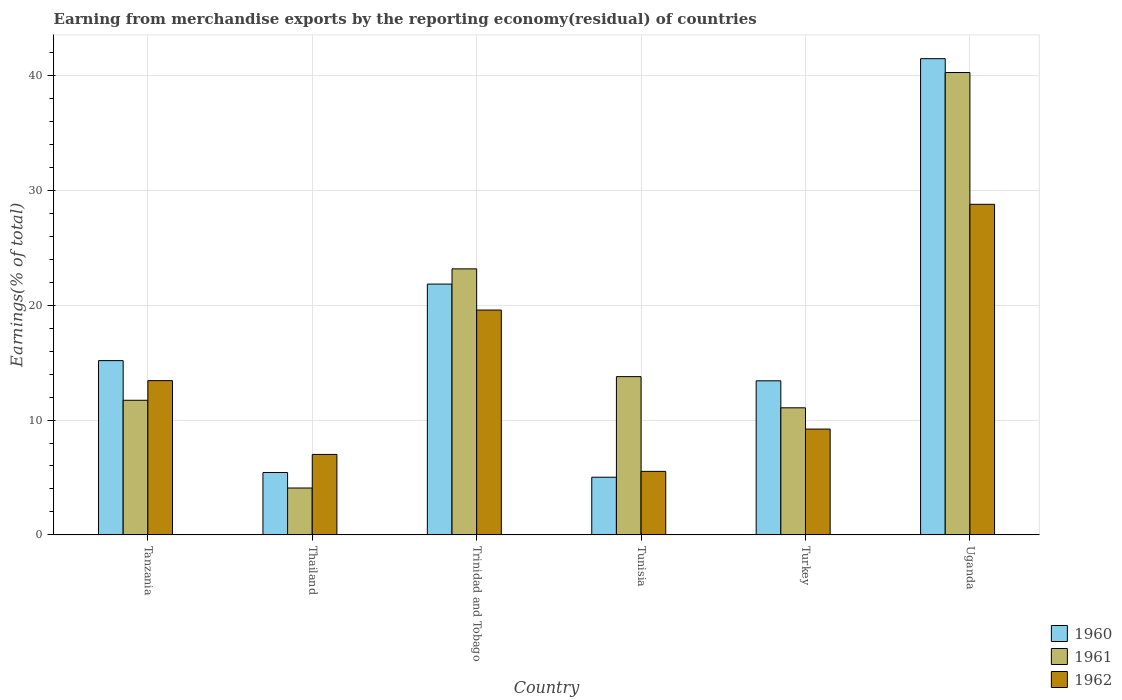How many different coloured bars are there?
Keep it short and to the point. 3. Are the number of bars per tick equal to the number of legend labels?
Keep it short and to the point. Yes. What is the label of the 1st group of bars from the left?
Provide a short and direct response. Tanzania. In how many cases, is the number of bars for a given country not equal to the number of legend labels?
Offer a very short reply. 0. What is the percentage of amount earned from merchandise exports in 1961 in Trinidad and Tobago?
Your answer should be very brief. 23.16. Across all countries, what is the maximum percentage of amount earned from merchandise exports in 1961?
Your answer should be compact. 40.26. Across all countries, what is the minimum percentage of amount earned from merchandise exports in 1961?
Your answer should be very brief. 4.08. In which country was the percentage of amount earned from merchandise exports in 1960 maximum?
Make the answer very short. Uganda. In which country was the percentage of amount earned from merchandise exports in 1960 minimum?
Keep it short and to the point. Tunisia. What is the total percentage of amount earned from merchandise exports in 1960 in the graph?
Ensure brevity in your answer.  102.35. What is the difference between the percentage of amount earned from merchandise exports in 1960 in Trinidad and Tobago and that in Turkey?
Provide a succinct answer. 8.42. What is the difference between the percentage of amount earned from merchandise exports in 1961 in Thailand and the percentage of amount earned from merchandise exports in 1960 in Tunisia?
Your answer should be very brief. -0.94. What is the average percentage of amount earned from merchandise exports in 1961 per country?
Provide a short and direct response. 17.35. What is the difference between the percentage of amount earned from merchandise exports of/in 1960 and percentage of amount earned from merchandise exports of/in 1961 in Trinidad and Tobago?
Give a very brief answer. -1.32. In how many countries, is the percentage of amount earned from merchandise exports in 1961 greater than 6 %?
Your response must be concise. 5. What is the ratio of the percentage of amount earned from merchandise exports in 1960 in Turkey to that in Uganda?
Your answer should be very brief. 0.32. Is the percentage of amount earned from merchandise exports in 1961 in Tanzania less than that in Turkey?
Your answer should be very brief. No. What is the difference between the highest and the second highest percentage of amount earned from merchandise exports in 1960?
Provide a succinct answer. 19.63. What is the difference between the highest and the lowest percentage of amount earned from merchandise exports in 1961?
Your response must be concise. 36.18. In how many countries, is the percentage of amount earned from merchandise exports in 1960 greater than the average percentage of amount earned from merchandise exports in 1960 taken over all countries?
Offer a terse response. 2. How many bars are there?
Give a very brief answer. 18. How many countries are there in the graph?
Your answer should be very brief. 6. What is the difference between two consecutive major ticks on the Y-axis?
Your answer should be compact. 10. Are the values on the major ticks of Y-axis written in scientific E-notation?
Your response must be concise. No. Does the graph contain any zero values?
Provide a short and direct response. No. Where does the legend appear in the graph?
Make the answer very short. Bottom right. How are the legend labels stacked?
Provide a succinct answer. Vertical. What is the title of the graph?
Ensure brevity in your answer.  Earning from merchandise exports by the reporting economy(residual) of countries. Does "1996" appear as one of the legend labels in the graph?
Ensure brevity in your answer.  No. What is the label or title of the X-axis?
Provide a short and direct response. Country. What is the label or title of the Y-axis?
Offer a very short reply. Earnings(% of total). What is the Earnings(% of total) of 1960 in Tanzania?
Your answer should be very brief. 15.18. What is the Earnings(% of total) of 1961 in Tanzania?
Your answer should be compact. 11.72. What is the Earnings(% of total) of 1962 in Tanzania?
Give a very brief answer. 13.43. What is the Earnings(% of total) of 1960 in Thailand?
Make the answer very short. 5.43. What is the Earnings(% of total) of 1961 in Thailand?
Your response must be concise. 4.08. What is the Earnings(% of total) in 1962 in Thailand?
Offer a very short reply. 7.01. What is the Earnings(% of total) of 1960 in Trinidad and Tobago?
Provide a succinct answer. 21.84. What is the Earnings(% of total) of 1961 in Trinidad and Tobago?
Ensure brevity in your answer.  23.16. What is the Earnings(% of total) in 1962 in Trinidad and Tobago?
Your answer should be very brief. 19.58. What is the Earnings(% of total) in 1960 in Tunisia?
Ensure brevity in your answer.  5.02. What is the Earnings(% of total) of 1961 in Tunisia?
Provide a short and direct response. 13.78. What is the Earnings(% of total) in 1962 in Tunisia?
Provide a short and direct response. 5.53. What is the Earnings(% of total) in 1960 in Turkey?
Offer a very short reply. 13.42. What is the Earnings(% of total) of 1961 in Turkey?
Your response must be concise. 11.07. What is the Earnings(% of total) of 1962 in Turkey?
Give a very brief answer. 9.22. What is the Earnings(% of total) in 1960 in Uganda?
Your answer should be compact. 41.47. What is the Earnings(% of total) in 1961 in Uganda?
Provide a succinct answer. 40.26. What is the Earnings(% of total) of 1962 in Uganda?
Offer a very short reply. 28.79. Across all countries, what is the maximum Earnings(% of total) of 1960?
Make the answer very short. 41.47. Across all countries, what is the maximum Earnings(% of total) in 1961?
Provide a succinct answer. 40.26. Across all countries, what is the maximum Earnings(% of total) in 1962?
Give a very brief answer. 28.79. Across all countries, what is the minimum Earnings(% of total) of 1960?
Make the answer very short. 5.02. Across all countries, what is the minimum Earnings(% of total) in 1961?
Make the answer very short. 4.08. Across all countries, what is the minimum Earnings(% of total) in 1962?
Provide a short and direct response. 5.53. What is the total Earnings(% of total) in 1960 in the graph?
Your answer should be compact. 102.35. What is the total Earnings(% of total) in 1961 in the graph?
Give a very brief answer. 104.08. What is the total Earnings(% of total) in 1962 in the graph?
Your answer should be very brief. 83.55. What is the difference between the Earnings(% of total) in 1960 in Tanzania and that in Thailand?
Offer a very short reply. 9.74. What is the difference between the Earnings(% of total) in 1961 in Tanzania and that in Thailand?
Offer a very short reply. 7.64. What is the difference between the Earnings(% of total) of 1962 in Tanzania and that in Thailand?
Make the answer very short. 6.43. What is the difference between the Earnings(% of total) in 1960 in Tanzania and that in Trinidad and Tobago?
Offer a very short reply. -6.66. What is the difference between the Earnings(% of total) of 1961 in Tanzania and that in Trinidad and Tobago?
Make the answer very short. -11.44. What is the difference between the Earnings(% of total) of 1962 in Tanzania and that in Trinidad and Tobago?
Your answer should be very brief. -6.14. What is the difference between the Earnings(% of total) in 1960 in Tanzania and that in Tunisia?
Ensure brevity in your answer.  10.15. What is the difference between the Earnings(% of total) of 1961 in Tanzania and that in Tunisia?
Your answer should be compact. -2.06. What is the difference between the Earnings(% of total) in 1962 in Tanzania and that in Tunisia?
Make the answer very short. 7.9. What is the difference between the Earnings(% of total) in 1960 in Tanzania and that in Turkey?
Offer a terse response. 1.76. What is the difference between the Earnings(% of total) of 1961 in Tanzania and that in Turkey?
Provide a short and direct response. 0.66. What is the difference between the Earnings(% of total) of 1962 in Tanzania and that in Turkey?
Keep it short and to the point. 4.22. What is the difference between the Earnings(% of total) in 1960 in Tanzania and that in Uganda?
Give a very brief answer. -26.29. What is the difference between the Earnings(% of total) in 1961 in Tanzania and that in Uganda?
Your answer should be very brief. -28.54. What is the difference between the Earnings(% of total) of 1962 in Tanzania and that in Uganda?
Your answer should be compact. -15.35. What is the difference between the Earnings(% of total) of 1960 in Thailand and that in Trinidad and Tobago?
Keep it short and to the point. -16.41. What is the difference between the Earnings(% of total) of 1961 in Thailand and that in Trinidad and Tobago?
Ensure brevity in your answer.  -19.08. What is the difference between the Earnings(% of total) in 1962 in Thailand and that in Trinidad and Tobago?
Provide a short and direct response. -12.57. What is the difference between the Earnings(% of total) in 1960 in Thailand and that in Tunisia?
Make the answer very short. 0.41. What is the difference between the Earnings(% of total) of 1961 in Thailand and that in Tunisia?
Your answer should be compact. -9.7. What is the difference between the Earnings(% of total) of 1962 in Thailand and that in Tunisia?
Offer a very short reply. 1.48. What is the difference between the Earnings(% of total) of 1960 in Thailand and that in Turkey?
Keep it short and to the point. -7.98. What is the difference between the Earnings(% of total) in 1961 in Thailand and that in Turkey?
Keep it short and to the point. -6.98. What is the difference between the Earnings(% of total) in 1962 in Thailand and that in Turkey?
Make the answer very short. -2.21. What is the difference between the Earnings(% of total) in 1960 in Thailand and that in Uganda?
Your response must be concise. -36.03. What is the difference between the Earnings(% of total) in 1961 in Thailand and that in Uganda?
Your response must be concise. -36.18. What is the difference between the Earnings(% of total) in 1962 in Thailand and that in Uganda?
Your answer should be compact. -21.78. What is the difference between the Earnings(% of total) of 1960 in Trinidad and Tobago and that in Tunisia?
Keep it short and to the point. 16.82. What is the difference between the Earnings(% of total) of 1961 in Trinidad and Tobago and that in Tunisia?
Give a very brief answer. 9.38. What is the difference between the Earnings(% of total) in 1962 in Trinidad and Tobago and that in Tunisia?
Your answer should be compact. 14.05. What is the difference between the Earnings(% of total) of 1960 in Trinidad and Tobago and that in Turkey?
Keep it short and to the point. 8.42. What is the difference between the Earnings(% of total) of 1961 in Trinidad and Tobago and that in Turkey?
Provide a succinct answer. 12.1. What is the difference between the Earnings(% of total) in 1962 in Trinidad and Tobago and that in Turkey?
Your answer should be very brief. 10.36. What is the difference between the Earnings(% of total) of 1960 in Trinidad and Tobago and that in Uganda?
Ensure brevity in your answer.  -19.63. What is the difference between the Earnings(% of total) in 1961 in Trinidad and Tobago and that in Uganda?
Provide a short and direct response. -17.1. What is the difference between the Earnings(% of total) in 1962 in Trinidad and Tobago and that in Uganda?
Offer a terse response. -9.21. What is the difference between the Earnings(% of total) in 1960 in Tunisia and that in Turkey?
Provide a short and direct response. -8.4. What is the difference between the Earnings(% of total) of 1961 in Tunisia and that in Turkey?
Offer a very short reply. 2.71. What is the difference between the Earnings(% of total) in 1962 in Tunisia and that in Turkey?
Your answer should be very brief. -3.68. What is the difference between the Earnings(% of total) of 1960 in Tunisia and that in Uganda?
Your response must be concise. -36.44. What is the difference between the Earnings(% of total) of 1961 in Tunisia and that in Uganda?
Provide a succinct answer. -26.48. What is the difference between the Earnings(% of total) in 1962 in Tunisia and that in Uganda?
Ensure brevity in your answer.  -23.25. What is the difference between the Earnings(% of total) of 1960 in Turkey and that in Uganda?
Your answer should be compact. -28.05. What is the difference between the Earnings(% of total) in 1961 in Turkey and that in Uganda?
Your response must be concise. -29.19. What is the difference between the Earnings(% of total) of 1962 in Turkey and that in Uganda?
Your answer should be compact. -19.57. What is the difference between the Earnings(% of total) in 1960 in Tanzania and the Earnings(% of total) in 1961 in Thailand?
Provide a short and direct response. 11.09. What is the difference between the Earnings(% of total) of 1960 in Tanzania and the Earnings(% of total) of 1962 in Thailand?
Keep it short and to the point. 8.17. What is the difference between the Earnings(% of total) of 1961 in Tanzania and the Earnings(% of total) of 1962 in Thailand?
Offer a very short reply. 4.72. What is the difference between the Earnings(% of total) in 1960 in Tanzania and the Earnings(% of total) in 1961 in Trinidad and Tobago?
Your answer should be compact. -7.99. What is the difference between the Earnings(% of total) of 1960 in Tanzania and the Earnings(% of total) of 1962 in Trinidad and Tobago?
Make the answer very short. -4.4. What is the difference between the Earnings(% of total) of 1961 in Tanzania and the Earnings(% of total) of 1962 in Trinidad and Tobago?
Make the answer very short. -7.86. What is the difference between the Earnings(% of total) of 1960 in Tanzania and the Earnings(% of total) of 1961 in Tunisia?
Offer a terse response. 1.39. What is the difference between the Earnings(% of total) of 1960 in Tanzania and the Earnings(% of total) of 1962 in Tunisia?
Your response must be concise. 9.64. What is the difference between the Earnings(% of total) of 1961 in Tanzania and the Earnings(% of total) of 1962 in Tunisia?
Ensure brevity in your answer.  6.19. What is the difference between the Earnings(% of total) of 1960 in Tanzania and the Earnings(% of total) of 1961 in Turkey?
Keep it short and to the point. 4.11. What is the difference between the Earnings(% of total) of 1960 in Tanzania and the Earnings(% of total) of 1962 in Turkey?
Provide a short and direct response. 5.96. What is the difference between the Earnings(% of total) of 1961 in Tanzania and the Earnings(% of total) of 1962 in Turkey?
Your response must be concise. 2.51. What is the difference between the Earnings(% of total) of 1960 in Tanzania and the Earnings(% of total) of 1961 in Uganda?
Offer a terse response. -25.09. What is the difference between the Earnings(% of total) in 1960 in Tanzania and the Earnings(% of total) in 1962 in Uganda?
Offer a terse response. -13.61. What is the difference between the Earnings(% of total) in 1961 in Tanzania and the Earnings(% of total) in 1962 in Uganda?
Your response must be concise. -17.06. What is the difference between the Earnings(% of total) in 1960 in Thailand and the Earnings(% of total) in 1961 in Trinidad and Tobago?
Your answer should be compact. -17.73. What is the difference between the Earnings(% of total) in 1960 in Thailand and the Earnings(% of total) in 1962 in Trinidad and Tobago?
Make the answer very short. -14.14. What is the difference between the Earnings(% of total) of 1961 in Thailand and the Earnings(% of total) of 1962 in Trinidad and Tobago?
Keep it short and to the point. -15.49. What is the difference between the Earnings(% of total) of 1960 in Thailand and the Earnings(% of total) of 1961 in Tunisia?
Your answer should be compact. -8.35. What is the difference between the Earnings(% of total) of 1960 in Thailand and the Earnings(% of total) of 1962 in Tunisia?
Provide a short and direct response. -0.1. What is the difference between the Earnings(% of total) of 1961 in Thailand and the Earnings(% of total) of 1962 in Tunisia?
Ensure brevity in your answer.  -1.45. What is the difference between the Earnings(% of total) in 1960 in Thailand and the Earnings(% of total) in 1961 in Turkey?
Give a very brief answer. -5.63. What is the difference between the Earnings(% of total) of 1960 in Thailand and the Earnings(% of total) of 1962 in Turkey?
Provide a short and direct response. -3.78. What is the difference between the Earnings(% of total) in 1961 in Thailand and the Earnings(% of total) in 1962 in Turkey?
Provide a short and direct response. -5.13. What is the difference between the Earnings(% of total) of 1960 in Thailand and the Earnings(% of total) of 1961 in Uganda?
Offer a terse response. -34.83. What is the difference between the Earnings(% of total) of 1960 in Thailand and the Earnings(% of total) of 1962 in Uganda?
Keep it short and to the point. -23.35. What is the difference between the Earnings(% of total) in 1961 in Thailand and the Earnings(% of total) in 1962 in Uganda?
Ensure brevity in your answer.  -24.7. What is the difference between the Earnings(% of total) of 1960 in Trinidad and Tobago and the Earnings(% of total) of 1961 in Tunisia?
Keep it short and to the point. 8.06. What is the difference between the Earnings(% of total) in 1960 in Trinidad and Tobago and the Earnings(% of total) in 1962 in Tunisia?
Your answer should be very brief. 16.31. What is the difference between the Earnings(% of total) in 1961 in Trinidad and Tobago and the Earnings(% of total) in 1962 in Tunisia?
Offer a terse response. 17.63. What is the difference between the Earnings(% of total) of 1960 in Trinidad and Tobago and the Earnings(% of total) of 1961 in Turkey?
Offer a very short reply. 10.77. What is the difference between the Earnings(% of total) in 1960 in Trinidad and Tobago and the Earnings(% of total) in 1962 in Turkey?
Your response must be concise. 12.62. What is the difference between the Earnings(% of total) of 1961 in Trinidad and Tobago and the Earnings(% of total) of 1962 in Turkey?
Make the answer very short. 13.95. What is the difference between the Earnings(% of total) of 1960 in Trinidad and Tobago and the Earnings(% of total) of 1961 in Uganda?
Keep it short and to the point. -18.42. What is the difference between the Earnings(% of total) in 1960 in Trinidad and Tobago and the Earnings(% of total) in 1962 in Uganda?
Provide a short and direct response. -6.95. What is the difference between the Earnings(% of total) of 1961 in Trinidad and Tobago and the Earnings(% of total) of 1962 in Uganda?
Provide a succinct answer. -5.62. What is the difference between the Earnings(% of total) in 1960 in Tunisia and the Earnings(% of total) in 1961 in Turkey?
Give a very brief answer. -6.05. What is the difference between the Earnings(% of total) in 1960 in Tunisia and the Earnings(% of total) in 1962 in Turkey?
Your response must be concise. -4.19. What is the difference between the Earnings(% of total) of 1961 in Tunisia and the Earnings(% of total) of 1962 in Turkey?
Give a very brief answer. 4.57. What is the difference between the Earnings(% of total) in 1960 in Tunisia and the Earnings(% of total) in 1961 in Uganda?
Offer a very short reply. -35.24. What is the difference between the Earnings(% of total) in 1960 in Tunisia and the Earnings(% of total) in 1962 in Uganda?
Your response must be concise. -23.76. What is the difference between the Earnings(% of total) of 1961 in Tunisia and the Earnings(% of total) of 1962 in Uganda?
Your answer should be compact. -15. What is the difference between the Earnings(% of total) in 1960 in Turkey and the Earnings(% of total) in 1961 in Uganda?
Offer a very short reply. -26.84. What is the difference between the Earnings(% of total) of 1960 in Turkey and the Earnings(% of total) of 1962 in Uganda?
Your answer should be very brief. -15.37. What is the difference between the Earnings(% of total) of 1961 in Turkey and the Earnings(% of total) of 1962 in Uganda?
Your answer should be very brief. -17.72. What is the average Earnings(% of total) of 1960 per country?
Your response must be concise. 17.06. What is the average Earnings(% of total) in 1961 per country?
Keep it short and to the point. 17.35. What is the average Earnings(% of total) of 1962 per country?
Make the answer very short. 13.92. What is the difference between the Earnings(% of total) in 1960 and Earnings(% of total) in 1961 in Tanzania?
Ensure brevity in your answer.  3.45. What is the difference between the Earnings(% of total) of 1960 and Earnings(% of total) of 1962 in Tanzania?
Provide a succinct answer. 1.74. What is the difference between the Earnings(% of total) in 1961 and Earnings(% of total) in 1962 in Tanzania?
Make the answer very short. -1.71. What is the difference between the Earnings(% of total) of 1960 and Earnings(% of total) of 1961 in Thailand?
Provide a short and direct response. 1.35. What is the difference between the Earnings(% of total) of 1960 and Earnings(% of total) of 1962 in Thailand?
Ensure brevity in your answer.  -1.57. What is the difference between the Earnings(% of total) in 1961 and Earnings(% of total) in 1962 in Thailand?
Offer a terse response. -2.92. What is the difference between the Earnings(% of total) in 1960 and Earnings(% of total) in 1961 in Trinidad and Tobago?
Offer a terse response. -1.32. What is the difference between the Earnings(% of total) in 1960 and Earnings(% of total) in 1962 in Trinidad and Tobago?
Offer a terse response. 2.26. What is the difference between the Earnings(% of total) of 1961 and Earnings(% of total) of 1962 in Trinidad and Tobago?
Your answer should be compact. 3.59. What is the difference between the Earnings(% of total) of 1960 and Earnings(% of total) of 1961 in Tunisia?
Give a very brief answer. -8.76. What is the difference between the Earnings(% of total) of 1960 and Earnings(% of total) of 1962 in Tunisia?
Your response must be concise. -0.51. What is the difference between the Earnings(% of total) in 1961 and Earnings(% of total) in 1962 in Tunisia?
Make the answer very short. 8.25. What is the difference between the Earnings(% of total) in 1960 and Earnings(% of total) in 1961 in Turkey?
Provide a succinct answer. 2.35. What is the difference between the Earnings(% of total) in 1960 and Earnings(% of total) in 1962 in Turkey?
Your answer should be very brief. 4.2. What is the difference between the Earnings(% of total) of 1961 and Earnings(% of total) of 1962 in Turkey?
Your answer should be compact. 1.85. What is the difference between the Earnings(% of total) in 1960 and Earnings(% of total) in 1961 in Uganda?
Ensure brevity in your answer.  1.2. What is the difference between the Earnings(% of total) in 1960 and Earnings(% of total) in 1962 in Uganda?
Your answer should be compact. 12.68. What is the difference between the Earnings(% of total) in 1961 and Earnings(% of total) in 1962 in Uganda?
Provide a succinct answer. 11.48. What is the ratio of the Earnings(% of total) in 1960 in Tanzania to that in Thailand?
Offer a very short reply. 2.79. What is the ratio of the Earnings(% of total) in 1961 in Tanzania to that in Thailand?
Your response must be concise. 2.87. What is the ratio of the Earnings(% of total) in 1962 in Tanzania to that in Thailand?
Keep it short and to the point. 1.92. What is the ratio of the Earnings(% of total) of 1960 in Tanzania to that in Trinidad and Tobago?
Make the answer very short. 0.69. What is the ratio of the Earnings(% of total) of 1961 in Tanzania to that in Trinidad and Tobago?
Provide a succinct answer. 0.51. What is the ratio of the Earnings(% of total) of 1962 in Tanzania to that in Trinidad and Tobago?
Keep it short and to the point. 0.69. What is the ratio of the Earnings(% of total) in 1960 in Tanzania to that in Tunisia?
Offer a terse response. 3.02. What is the ratio of the Earnings(% of total) in 1961 in Tanzania to that in Tunisia?
Make the answer very short. 0.85. What is the ratio of the Earnings(% of total) of 1962 in Tanzania to that in Tunisia?
Give a very brief answer. 2.43. What is the ratio of the Earnings(% of total) of 1960 in Tanzania to that in Turkey?
Your answer should be very brief. 1.13. What is the ratio of the Earnings(% of total) of 1961 in Tanzania to that in Turkey?
Keep it short and to the point. 1.06. What is the ratio of the Earnings(% of total) of 1962 in Tanzania to that in Turkey?
Your response must be concise. 1.46. What is the ratio of the Earnings(% of total) of 1960 in Tanzania to that in Uganda?
Make the answer very short. 0.37. What is the ratio of the Earnings(% of total) of 1961 in Tanzania to that in Uganda?
Offer a terse response. 0.29. What is the ratio of the Earnings(% of total) of 1962 in Tanzania to that in Uganda?
Offer a terse response. 0.47. What is the ratio of the Earnings(% of total) in 1960 in Thailand to that in Trinidad and Tobago?
Provide a succinct answer. 0.25. What is the ratio of the Earnings(% of total) of 1961 in Thailand to that in Trinidad and Tobago?
Your answer should be very brief. 0.18. What is the ratio of the Earnings(% of total) of 1962 in Thailand to that in Trinidad and Tobago?
Provide a succinct answer. 0.36. What is the ratio of the Earnings(% of total) in 1960 in Thailand to that in Tunisia?
Keep it short and to the point. 1.08. What is the ratio of the Earnings(% of total) in 1961 in Thailand to that in Tunisia?
Ensure brevity in your answer.  0.3. What is the ratio of the Earnings(% of total) in 1962 in Thailand to that in Tunisia?
Your answer should be very brief. 1.27. What is the ratio of the Earnings(% of total) of 1960 in Thailand to that in Turkey?
Your answer should be very brief. 0.4. What is the ratio of the Earnings(% of total) of 1961 in Thailand to that in Turkey?
Your answer should be very brief. 0.37. What is the ratio of the Earnings(% of total) in 1962 in Thailand to that in Turkey?
Offer a terse response. 0.76. What is the ratio of the Earnings(% of total) of 1960 in Thailand to that in Uganda?
Keep it short and to the point. 0.13. What is the ratio of the Earnings(% of total) in 1961 in Thailand to that in Uganda?
Your answer should be very brief. 0.1. What is the ratio of the Earnings(% of total) in 1962 in Thailand to that in Uganda?
Ensure brevity in your answer.  0.24. What is the ratio of the Earnings(% of total) of 1960 in Trinidad and Tobago to that in Tunisia?
Keep it short and to the point. 4.35. What is the ratio of the Earnings(% of total) of 1961 in Trinidad and Tobago to that in Tunisia?
Your answer should be compact. 1.68. What is the ratio of the Earnings(% of total) of 1962 in Trinidad and Tobago to that in Tunisia?
Your response must be concise. 3.54. What is the ratio of the Earnings(% of total) in 1960 in Trinidad and Tobago to that in Turkey?
Ensure brevity in your answer.  1.63. What is the ratio of the Earnings(% of total) of 1961 in Trinidad and Tobago to that in Turkey?
Your answer should be compact. 2.09. What is the ratio of the Earnings(% of total) in 1962 in Trinidad and Tobago to that in Turkey?
Your answer should be compact. 2.12. What is the ratio of the Earnings(% of total) in 1960 in Trinidad and Tobago to that in Uganda?
Provide a succinct answer. 0.53. What is the ratio of the Earnings(% of total) in 1961 in Trinidad and Tobago to that in Uganda?
Offer a terse response. 0.58. What is the ratio of the Earnings(% of total) in 1962 in Trinidad and Tobago to that in Uganda?
Make the answer very short. 0.68. What is the ratio of the Earnings(% of total) in 1960 in Tunisia to that in Turkey?
Keep it short and to the point. 0.37. What is the ratio of the Earnings(% of total) of 1961 in Tunisia to that in Turkey?
Keep it short and to the point. 1.25. What is the ratio of the Earnings(% of total) in 1962 in Tunisia to that in Turkey?
Ensure brevity in your answer.  0.6. What is the ratio of the Earnings(% of total) of 1960 in Tunisia to that in Uganda?
Your answer should be compact. 0.12. What is the ratio of the Earnings(% of total) in 1961 in Tunisia to that in Uganda?
Give a very brief answer. 0.34. What is the ratio of the Earnings(% of total) of 1962 in Tunisia to that in Uganda?
Offer a very short reply. 0.19. What is the ratio of the Earnings(% of total) of 1960 in Turkey to that in Uganda?
Offer a terse response. 0.32. What is the ratio of the Earnings(% of total) of 1961 in Turkey to that in Uganda?
Your response must be concise. 0.27. What is the ratio of the Earnings(% of total) in 1962 in Turkey to that in Uganda?
Offer a terse response. 0.32. What is the difference between the highest and the second highest Earnings(% of total) in 1960?
Ensure brevity in your answer.  19.63. What is the difference between the highest and the second highest Earnings(% of total) in 1961?
Ensure brevity in your answer.  17.1. What is the difference between the highest and the second highest Earnings(% of total) of 1962?
Ensure brevity in your answer.  9.21. What is the difference between the highest and the lowest Earnings(% of total) in 1960?
Provide a succinct answer. 36.44. What is the difference between the highest and the lowest Earnings(% of total) in 1961?
Provide a short and direct response. 36.18. What is the difference between the highest and the lowest Earnings(% of total) in 1962?
Keep it short and to the point. 23.25. 